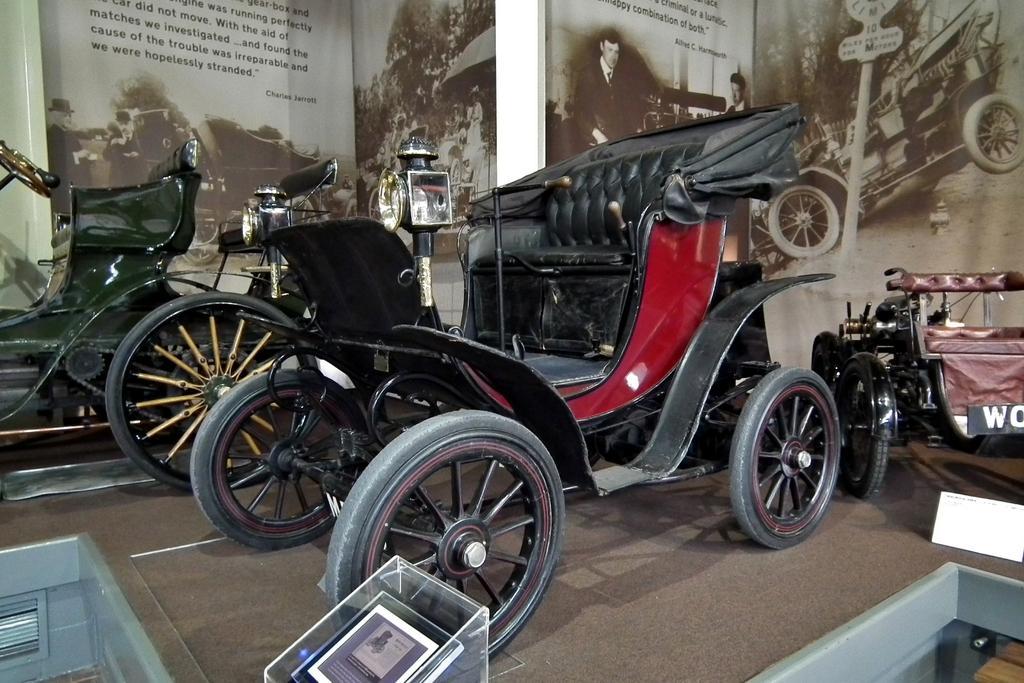Please provide a concise description of this image. In this picture there is a vehicle in the center of the image and there are other vehicles on the right and left side of the image, there are posters in the background area of the image. 